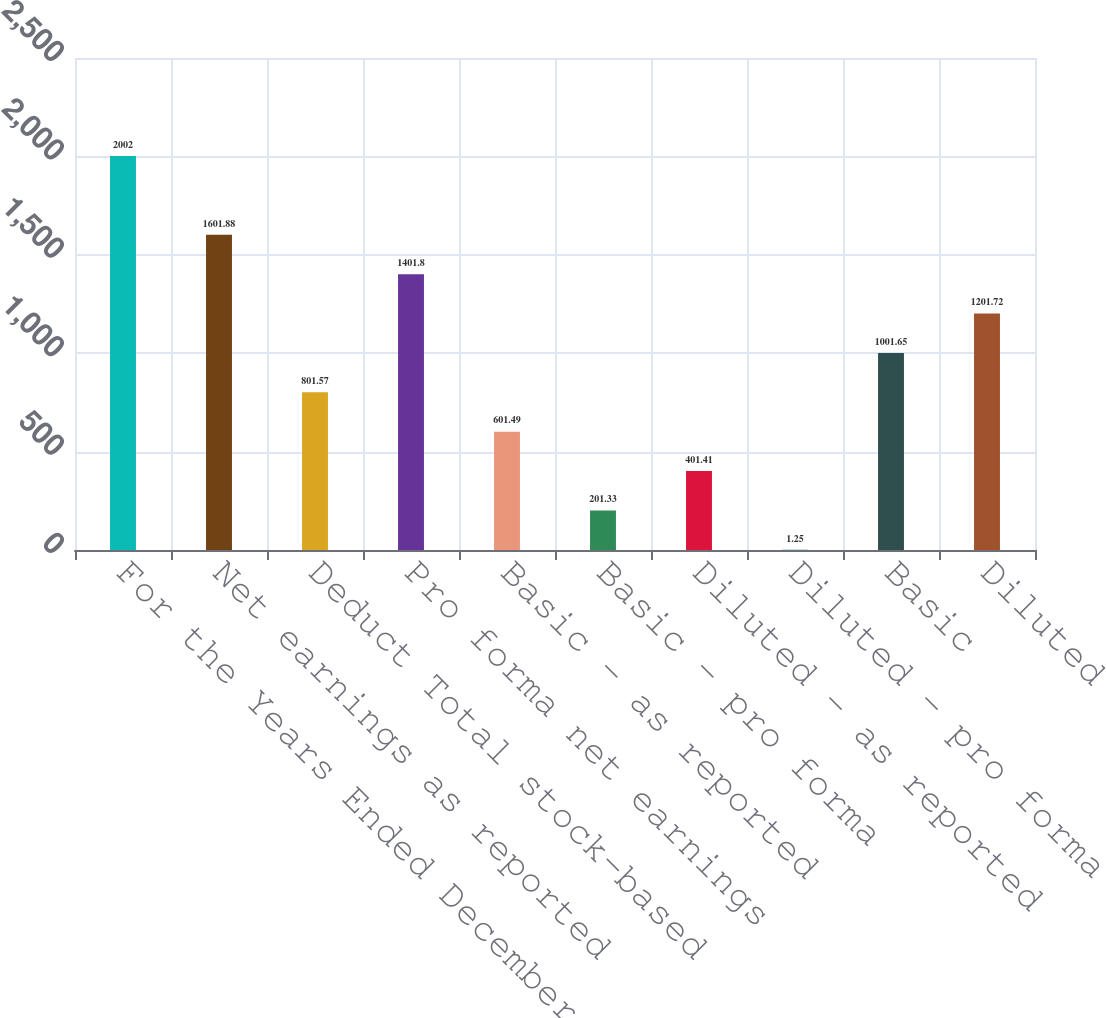<chart> <loc_0><loc_0><loc_500><loc_500><bar_chart><fcel>For the Years Ended December<fcel>Net earnings as reported<fcel>Deduct Total stock-based<fcel>Pro forma net earnings<fcel>Basic - as reported<fcel>Basic - pro forma<fcel>Diluted - as reported<fcel>Diluted - pro forma<fcel>Basic<fcel>Diluted<nl><fcel>2002<fcel>1601.88<fcel>801.57<fcel>1401.8<fcel>601.49<fcel>201.33<fcel>401.41<fcel>1.25<fcel>1001.65<fcel>1201.72<nl></chart> 